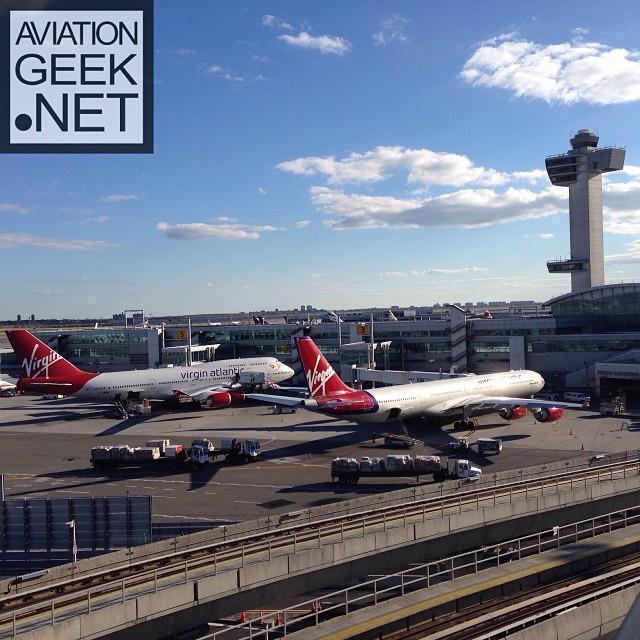What other item did the company whose name appears on the large vehicle make?
Indicate the correct response by choosing from the four available options to answer the question.
Options: Hot dogs, televisions, phones, hamburgers. Phones. What state has a name closest to the name that is found on the vehicle?
Select the accurate response from the four choices given to answer the question.
Options: Virginia, new jersey, fordham, delaware. Virginia. 